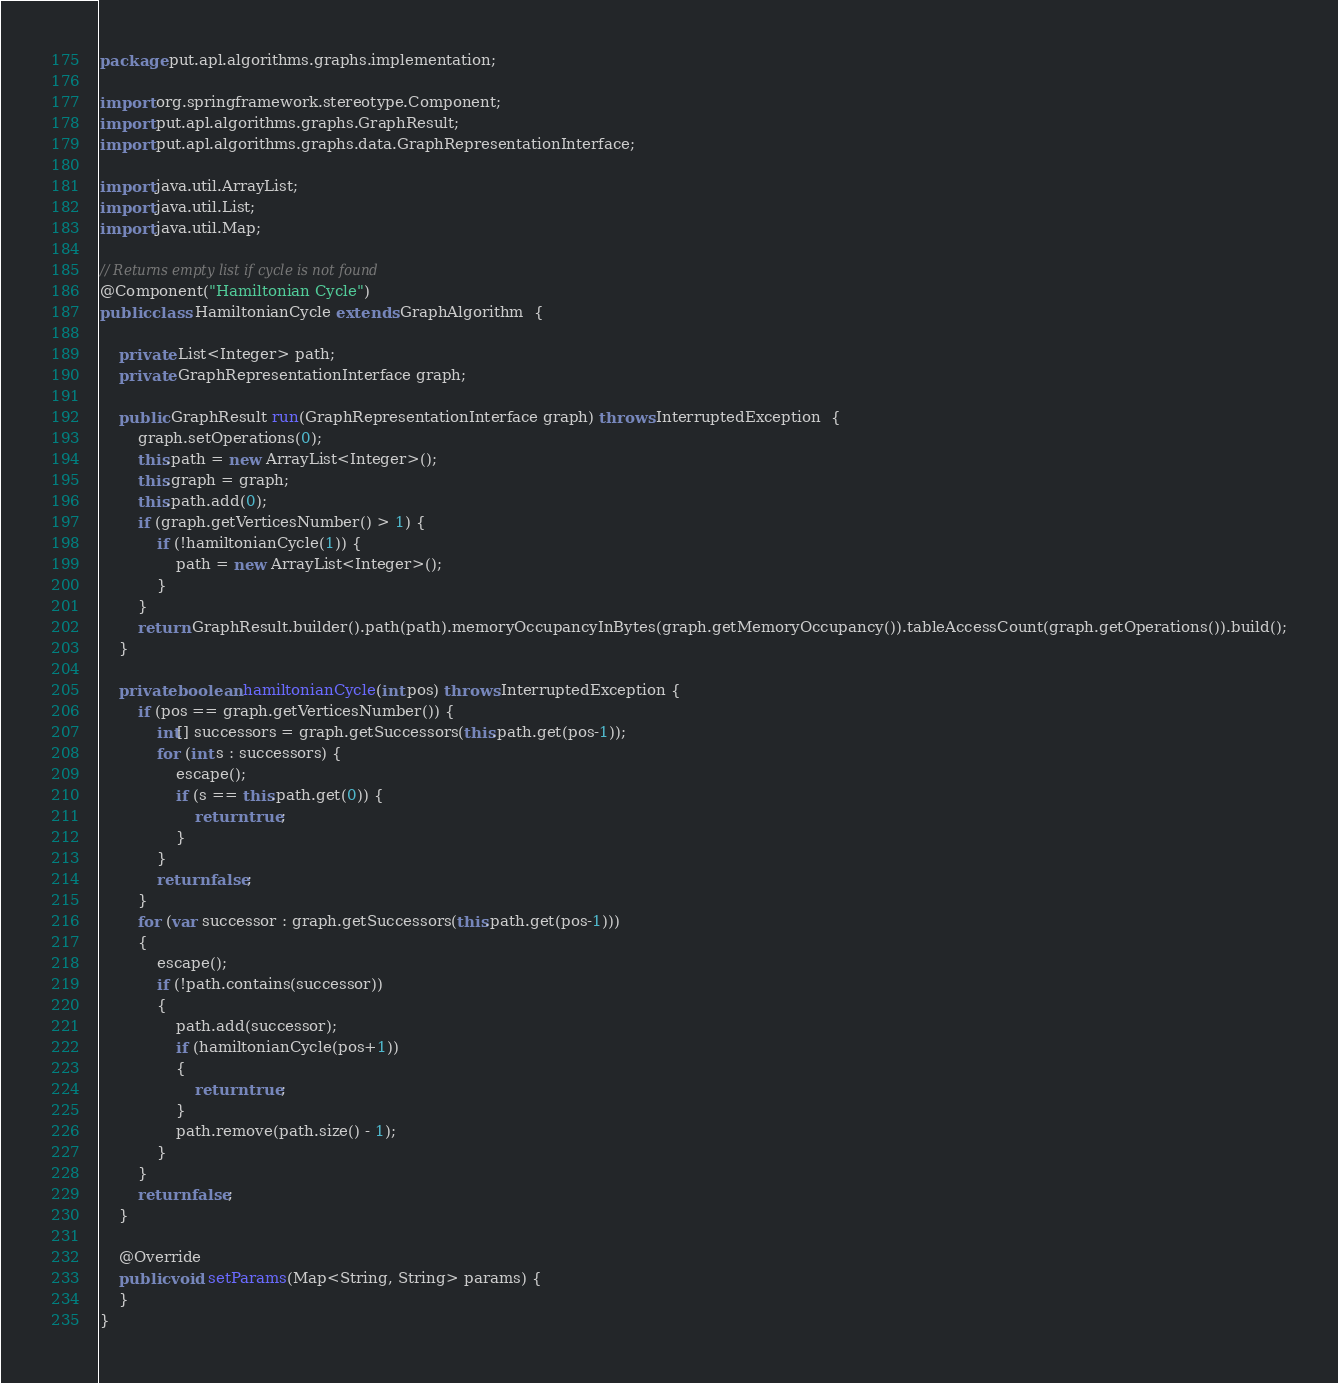Convert code to text. <code><loc_0><loc_0><loc_500><loc_500><_Java_>package put.apl.algorithms.graphs.implementation;

import org.springframework.stereotype.Component;
import put.apl.algorithms.graphs.GraphResult;
import put.apl.algorithms.graphs.data.GraphRepresentationInterface;

import java.util.ArrayList;
import java.util.List;
import java.util.Map;

// Returns empty list if cycle is not found
@Component("Hamiltonian Cycle")
public class HamiltonianCycle extends GraphAlgorithm  {

    private List<Integer> path;
    private GraphRepresentationInterface graph;

    public GraphResult run(GraphRepresentationInterface graph) throws InterruptedException  {
        graph.setOperations(0);
        this.path = new ArrayList<Integer>();
        this.graph = graph;
        this.path.add(0);
        if (graph.getVerticesNumber() > 1) {
            if (!hamiltonianCycle(1)) {
                path = new ArrayList<Integer>();
            }
        }
        return GraphResult.builder().path(path).memoryOccupancyInBytes(graph.getMemoryOccupancy()).tableAccessCount(graph.getOperations()).build();
    }

    private boolean hamiltonianCycle(int pos) throws InterruptedException {
        if (pos == graph.getVerticesNumber()) {
            int[] successors = graph.getSuccessors(this.path.get(pos-1));
            for (int s : successors) {
                escape();
                if (s == this.path.get(0)) {
                    return true;
                }
            }
            return false;
        }
        for (var successor : graph.getSuccessors(this.path.get(pos-1)))
        {
            escape();
            if (!path.contains(successor))
            {
                path.add(successor);
                if (hamiltonianCycle(pos+1))
                {
                    return true;
                }
                path.remove(path.size() - 1);
            }
        }
        return false;
    }

    @Override
    public void setParams(Map<String, String> params) {
    }
}
</code> 